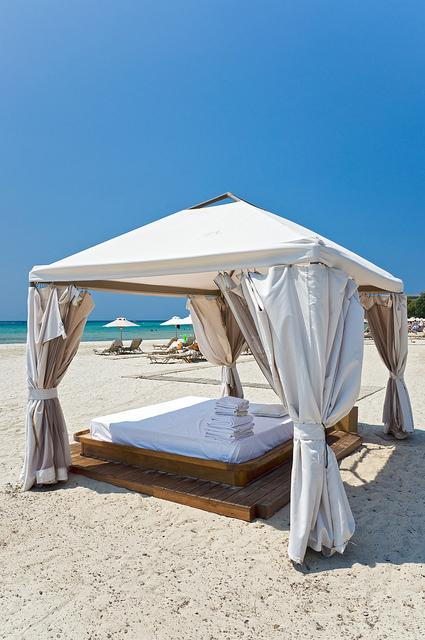What will this tent offer protection from? Please explain your reasoning. sun. The tent has fabric that is used for protection from the sun. 